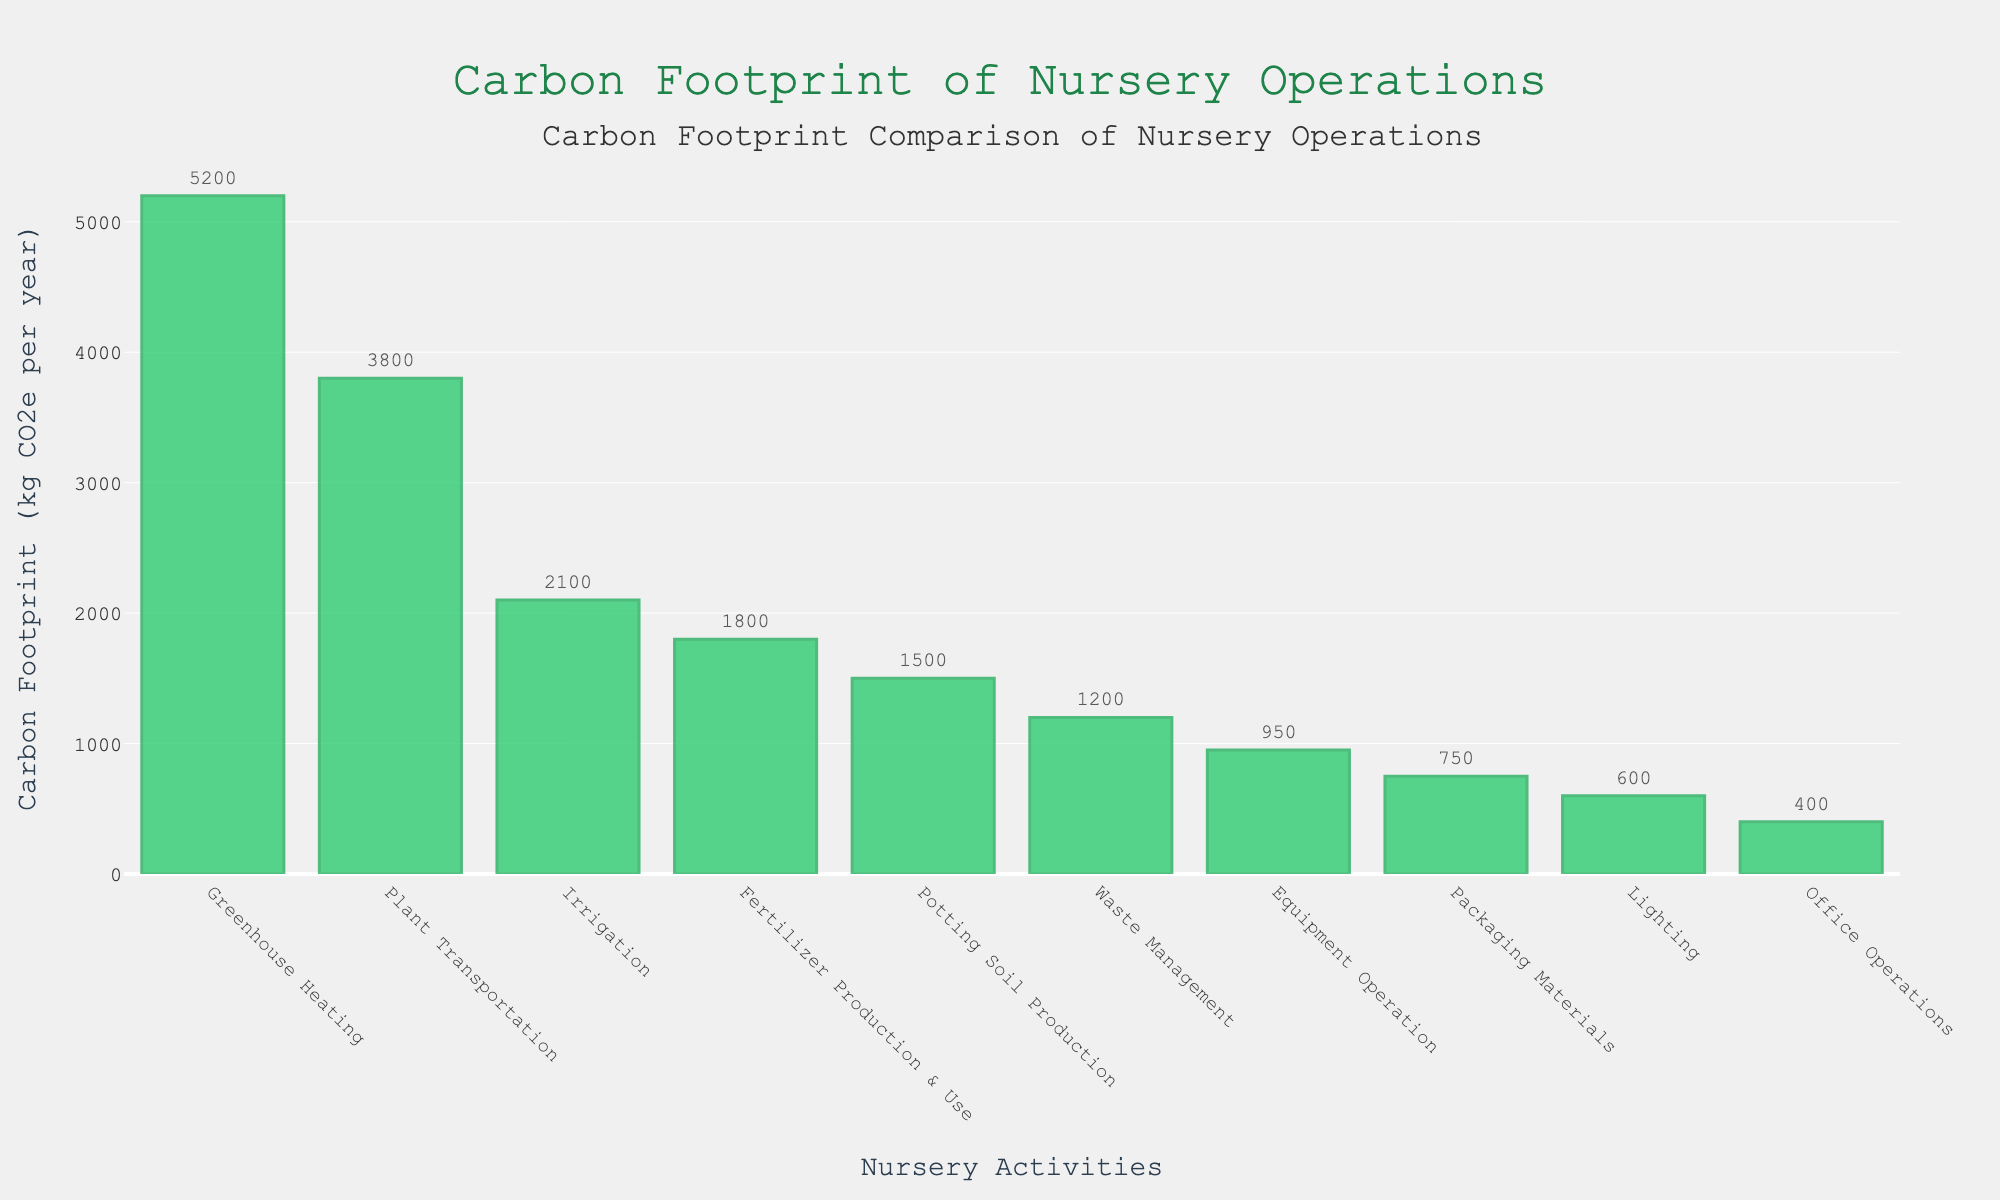Which activity has the highest carbon footprint? The activity with the tallest bar indicates the highest carbon footprint. From the bar chart, Greenhouse Heating has the tallest bar.
Answer: Greenhouse Heating Which activity has a lower carbon footprint: Equipment Operation or Waste Management? Waste Management's bar is higher than Equipment Operation's bar, meaning Equipment Operation has a lower carbon footprint.
Answer: Equipment Operation What's the total carbon footprint of Plant Transportation and Packaging Materials combined? To find the total, sum the values for Plant Transportation (3800 kg CO2e) and Packaging Materials (750 kg CO2e). 3800 + 750 = 4550.
Answer: 4550 kg CO2e How does the carbon footprint of Irrigation compare to that of Lighting? The bar for Irrigation is taller than the bar for Lighting, indicating that the carbon footprint for Irrigation is greater than for Lighting.
Answer: Irrigation has a greater carbon footprint than Lighting What's the average carbon footprint of Greenhouse Heating, Plant Transportation, and Irrigation? To calculate the average, sum the footprints of Greenhouse Heating (5200 kg CO2e), Plant Transportation (3800 kg CO2e), and Irrigation (2100 kg CO2e) and divide by 3. (5200 + 3800 + 2100) / 3 = 11100 / 3 = 3700.
Answer: 3700 kg CO2e What is the difference in carbon footprint between Fertilizer Production & Use and Office Operations? To find the difference, subtract the carbon footprint of Office Operations (400 kg CO2e) from Fertilizer Production & Use (1800 kg CO2e). 1800 - 400 = 1400.
Answer: 1400 kg CO2e How much greater is the carbon footprint of Greenhouse Heating compared to Packaging Materials? Subtract the carbon footprint of Packaging Materials (750 kg CO2e) from Greenhouse Heating (5200 kg CO2e). 5200 - 750 = 4450.
Answer: 4450 kg CO2e Which three activities have the smallest carbon footprints? The three activities with the shortest bars are Office Operations (400 kg CO2e), Lighting (600 kg CO2e), and Packaging Materials (750 kg CO2e).
Answer: Office Operations, Lighting, Packaging Materials 